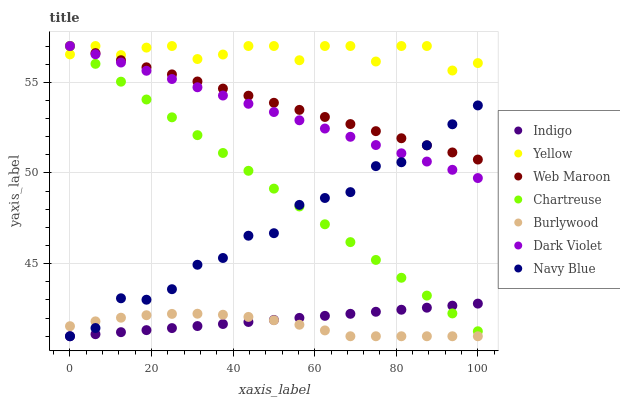Does Burlywood have the minimum area under the curve?
Answer yes or no. Yes. Does Yellow have the maximum area under the curve?
Answer yes or no. Yes. Does Navy Blue have the minimum area under the curve?
Answer yes or no. No. Does Navy Blue have the maximum area under the curve?
Answer yes or no. No. Is Web Maroon the smoothest?
Answer yes or no. Yes. Is Yellow the roughest?
Answer yes or no. Yes. Is Burlywood the smoothest?
Answer yes or no. No. Is Burlywood the roughest?
Answer yes or no. No. Does Indigo have the lowest value?
Answer yes or no. Yes. Does Web Maroon have the lowest value?
Answer yes or no. No. Does Yellow have the highest value?
Answer yes or no. Yes. Does Navy Blue have the highest value?
Answer yes or no. No. Is Burlywood less than Web Maroon?
Answer yes or no. Yes. Is Dark Violet greater than Indigo?
Answer yes or no. Yes. Does Chartreuse intersect Indigo?
Answer yes or no. Yes. Is Chartreuse less than Indigo?
Answer yes or no. No. Is Chartreuse greater than Indigo?
Answer yes or no. No. Does Burlywood intersect Web Maroon?
Answer yes or no. No. 